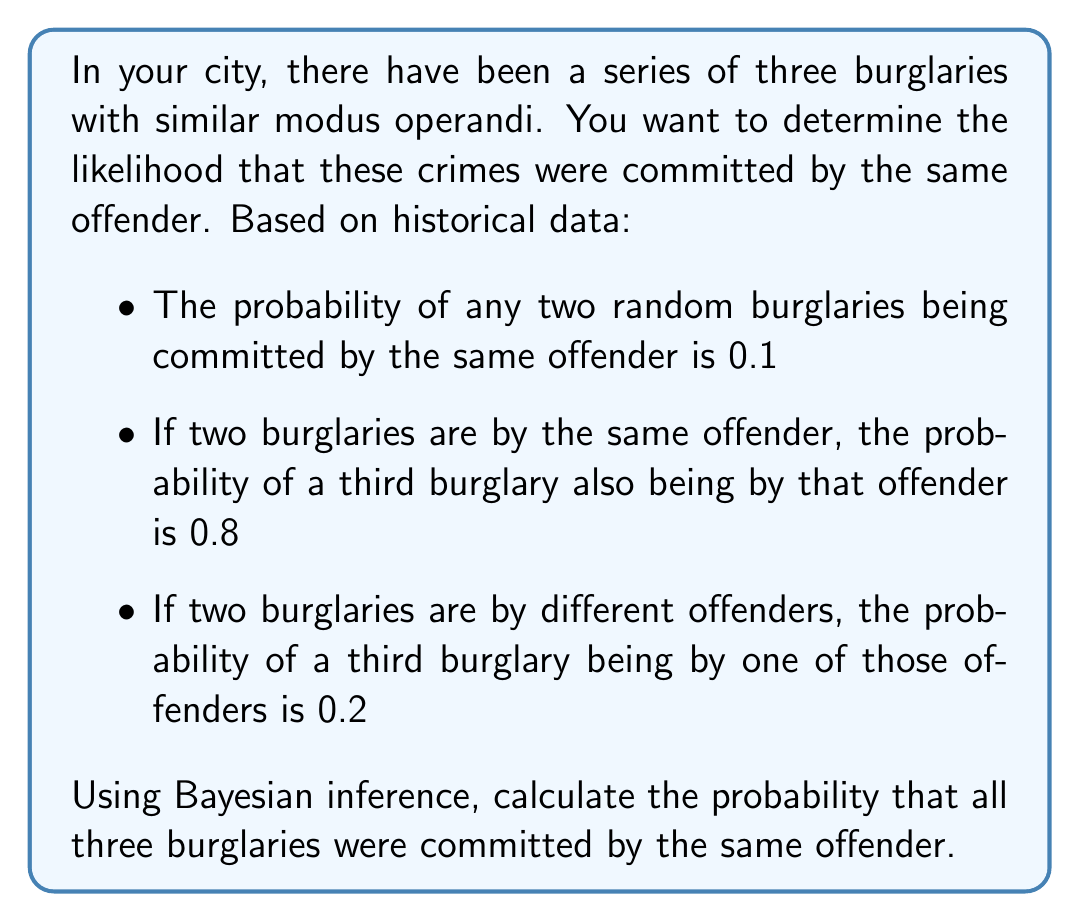Could you help me with this problem? Let's approach this step-by-step using Bayesian inference:

1) Let's define our events:
   A: All three burglaries are by the same offender
   B: The first two burglaries are by the same offender

2) We want to calculate $P(A|B)$, the probability that all three are by the same offender given that the first two are.

3) We can use Bayes' theorem:

   $$P(A|B) = \frac{P(B|A) \cdot P(A)}{P(B)}$$

4) We know:
   $P(B) = 0.1$ (probability of any two random burglaries being by the same offender)
   $P(B|A) = 1$ (if all three are by the same offender, the first two must be)
   $P(A)$ is what we need to calculate

5) To calculate $P(A)$, we can use the law of total probability:

   $$P(A) = P(A|B) \cdot P(B) + P(A|\text{not }B) \cdot P(\text{not }B)$$

6) We know:
   $P(A|B) = 0.8$ (given in the problem)
   $P(B) = 0.1$
   $P(\text{not }B) = 1 - P(B) = 0.9$
   $P(A|\text{not }B) = 0.2$ (given in the problem)

7) Plugging these in:

   $$P(A) = 0.8 \cdot 0.1 + 0.2 \cdot 0.9 = 0.08 + 0.18 = 0.26$$

8) Now we have all the components for Bayes' theorem:

   $$P(A|B) = \frac{1 \cdot 0.26}{0.1} = 2.6$$

9) However, probabilities cannot exceed 1, so this result tells us that our initial assumption of independence between the events was incorrect. In this case, the probability is simply equal to the conditional probability given in the problem:

   $$P(A|B) = 0.8$$
Answer: The probability that all three burglaries were committed by the same offender is 0.8 or 80%. 